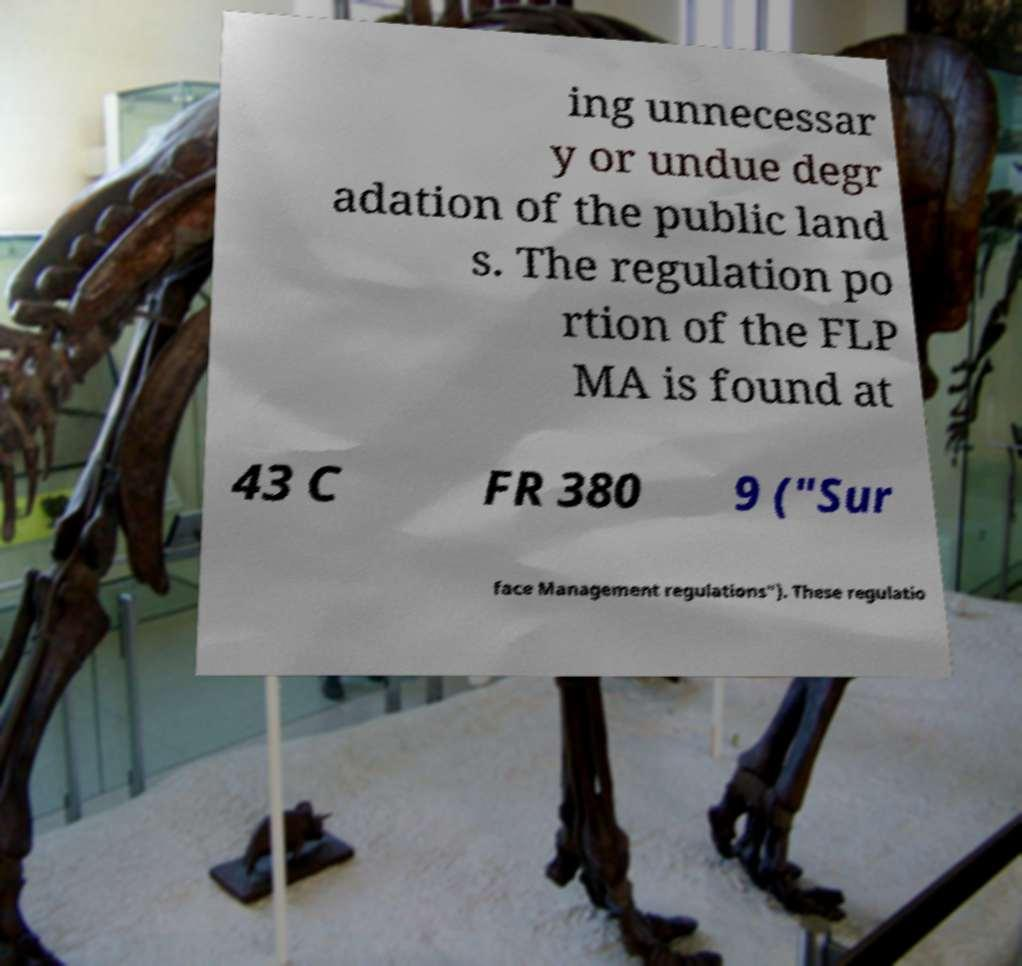Can you read and provide the text displayed in the image?This photo seems to have some interesting text. Can you extract and type it out for me? ing unnecessar y or undue degr adation of the public land s. The regulation po rtion of the FLP MA is found at 43 C FR 380 9 ("Sur face Management regulations"). These regulatio 